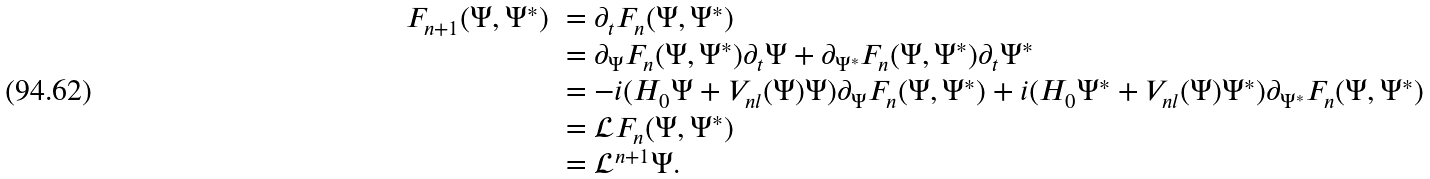<formula> <loc_0><loc_0><loc_500><loc_500>\begin{array} { l l } F _ { n + 1 } ( \Psi , \Psi ^ { * } ) & = \partial _ { t } F _ { n } ( \Psi , \Psi ^ { * } ) \\ & = \partial _ { \Psi } F _ { n } ( \Psi , \Psi ^ { * } ) \partial _ { t } \Psi + \partial _ { \Psi ^ { * } } F _ { n } ( \Psi , \Psi ^ { * } ) \partial _ { t } \Psi ^ { * } \\ & = - i ( H _ { 0 } \Psi + V _ { n l } ( \Psi ) \Psi ) \partial _ { \Psi } F _ { n } ( \Psi , \Psi ^ { * } ) + i ( H _ { 0 } \Psi ^ { * } + V _ { n l } ( \Psi ) \Psi ^ { * } ) \partial _ { \Psi ^ { * } } F _ { n } ( \Psi , \Psi ^ { * } ) \\ & = \mathcal { L } F _ { n } ( \Psi , \Psi ^ { * } ) \\ & = \mathcal { L } ^ { n + 1 } \Psi . \end{array}</formula> 